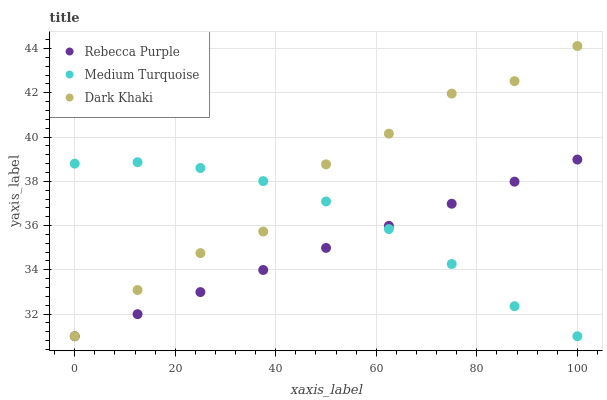Does Rebecca Purple have the minimum area under the curve?
Answer yes or no. Yes. Does Dark Khaki have the maximum area under the curve?
Answer yes or no. Yes. Does Medium Turquoise have the minimum area under the curve?
Answer yes or no. No. Does Medium Turquoise have the maximum area under the curve?
Answer yes or no. No. Is Rebecca Purple the smoothest?
Answer yes or no. Yes. Is Dark Khaki the roughest?
Answer yes or no. Yes. Is Medium Turquoise the smoothest?
Answer yes or no. No. Is Medium Turquoise the roughest?
Answer yes or no. No. Does Dark Khaki have the lowest value?
Answer yes or no. Yes. Does Dark Khaki have the highest value?
Answer yes or no. Yes. Does Rebecca Purple have the highest value?
Answer yes or no. No. Does Medium Turquoise intersect Rebecca Purple?
Answer yes or no. Yes. Is Medium Turquoise less than Rebecca Purple?
Answer yes or no. No. Is Medium Turquoise greater than Rebecca Purple?
Answer yes or no. No. 